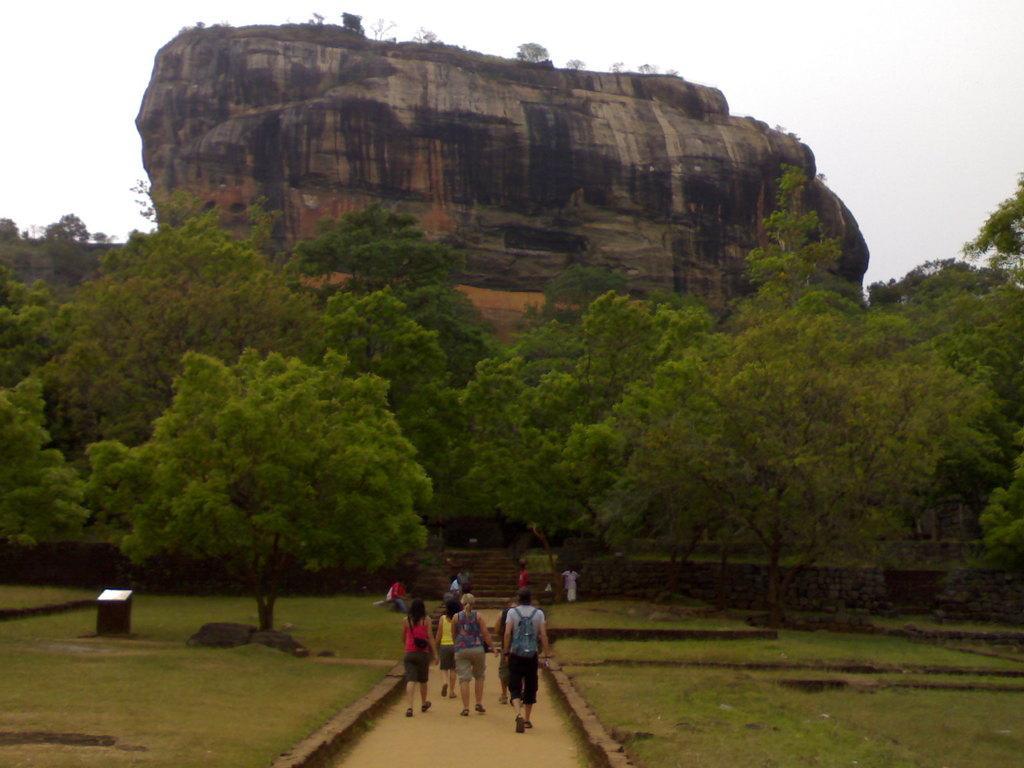In one or two sentences, can you explain what this image depicts? In the image we can see there are people walking, wearing clothes, shoes and some of them are carrying bags. Here we can see the path, grass, trees, rock and the sky. 